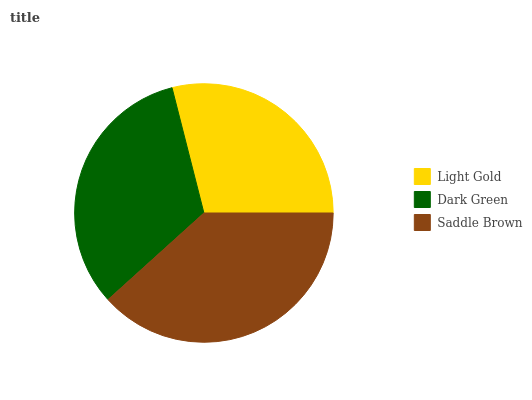Is Light Gold the minimum?
Answer yes or no. Yes. Is Saddle Brown the maximum?
Answer yes or no. Yes. Is Dark Green the minimum?
Answer yes or no. No. Is Dark Green the maximum?
Answer yes or no. No. Is Dark Green greater than Light Gold?
Answer yes or no. Yes. Is Light Gold less than Dark Green?
Answer yes or no. Yes. Is Light Gold greater than Dark Green?
Answer yes or no. No. Is Dark Green less than Light Gold?
Answer yes or no. No. Is Dark Green the high median?
Answer yes or no. Yes. Is Dark Green the low median?
Answer yes or no. Yes. Is Saddle Brown the high median?
Answer yes or no. No. Is Saddle Brown the low median?
Answer yes or no. No. 